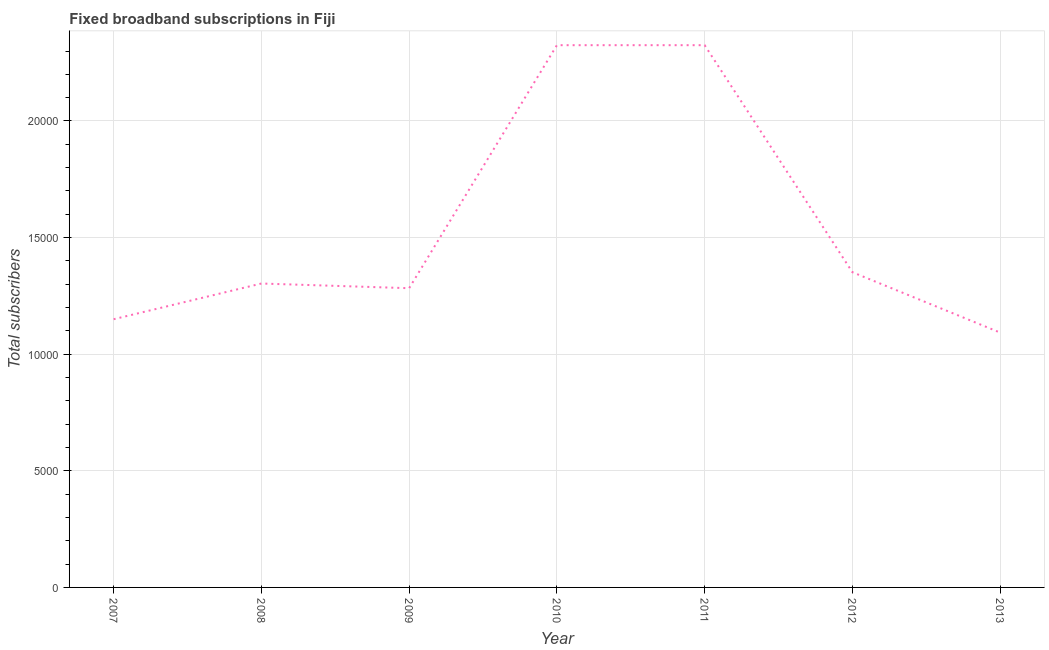What is the total number of fixed broadband subscriptions in 2010?
Your answer should be compact. 2.32e+04. Across all years, what is the maximum total number of fixed broadband subscriptions?
Give a very brief answer. 2.32e+04. Across all years, what is the minimum total number of fixed broadband subscriptions?
Your answer should be compact. 1.09e+04. In which year was the total number of fixed broadband subscriptions maximum?
Give a very brief answer. 2010. What is the sum of the total number of fixed broadband subscriptions?
Your answer should be compact. 1.08e+05. What is the average total number of fixed broadband subscriptions per year?
Provide a short and direct response. 1.55e+04. What is the median total number of fixed broadband subscriptions?
Provide a short and direct response. 1.30e+04. What is the ratio of the total number of fixed broadband subscriptions in 2010 to that in 2013?
Offer a terse response. 2.13. Is the total number of fixed broadband subscriptions in 2012 less than that in 2013?
Offer a terse response. No. Is the difference between the total number of fixed broadband subscriptions in 2008 and 2013 greater than the difference between any two years?
Ensure brevity in your answer.  No. What is the difference between the highest and the second highest total number of fixed broadband subscriptions?
Your answer should be compact. 0. Is the sum of the total number of fixed broadband subscriptions in 2007 and 2012 greater than the maximum total number of fixed broadband subscriptions across all years?
Keep it short and to the point. Yes. What is the difference between the highest and the lowest total number of fixed broadband subscriptions?
Keep it short and to the point. 1.23e+04. In how many years, is the total number of fixed broadband subscriptions greater than the average total number of fixed broadband subscriptions taken over all years?
Make the answer very short. 2. Does the total number of fixed broadband subscriptions monotonically increase over the years?
Make the answer very short. No. How many lines are there?
Provide a short and direct response. 1. How many years are there in the graph?
Ensure brevity in your answer.  7. Does the graph contain grids?
Offer a terse response. Yes. What is the title of the graph?
Keep it short and to the point. Fixed broadband subscriptions in Fiji. What is the label or title of the X-axis?
Give a very brief answer. Year. What is the label or title of the Y-axis?
Your response must be concise. Total subscribers. What is the Total subscribers of 2007?
Ensure brevity in your answer.  1.15e+04. What is the Total subscribers of 2008?
Offer a very short reply. 1.30e+04. What is the Total subscribers in 2009?
Make the answer very short. 1.28e+04. What is the Total subscribers in 2010?
Keep it short and to the point. 2.32e+04. What is the Total subscribers in 2011?
Offer a very short reply. 2.32e+04. What is the Total subscribers in 2012?
Your response must be concise. 1.35e+04. What is the Total subscribers in 2013?
Your answer should be very brief. 1.09e+04. What is the difference between the Total subscribers in 2007 and 2008?
Offer a terse response. -1531. What is the difference between the Total subscribers in 2007 and 2009?
Your answer should be compact. -1330. What is the difference between the Total subscribers in 2007 and 2010?
Your answer should be compact. -1.18e+04. What is the difference between the Total subscribers in 2007 and 2011?
Offer a terse response. -1.18e+04. What is the difference between the Total subscribers in 2007 and 2012?
Make the answer very short. -2016. What is the difference between the Total subscribers in 2007 and 2013?
Provide a short and direct response. 573. What is the difference between the Total subscribers in 2008 and 2009?
Keep it short and to the point. 201. What is the difference between the Total subscribers in 2008 and 2010?
Your answer should be compact. -1.02e+04. What is the difference between the Total subscribers in 2008 and 2011?
Provide a short and direct response. -1.02e+04. What is the difference between the Total subscribers in 2008 and 2012?
Offer a very short reply. -485. What is the difference between the Total subscribers in 2008 and 2013?
Give a very brief answer. 2104. What is the difference between the Total subscribers in 2009 and 2010?
Give a very brief answer. -1.04e+04. What is the difference between the Total subscribers in 2009 and 2011?
Make the answer very short. -1.04e+04. What is the difference between the Total subscribers in 2009 and 2012?
Your answer should be very brief. -686. What is the difference between the Total subscribers in 2009 and 2013?
Keep it short and to the point. 1903. What is the difference between the Total subscribers in 2010 and 2011?
Offer a very short reply. 0. What is the difference between the Total subscribers in 2010 and 2012?
Provide a short and direct response. 9734. What is the difference between the Total subscribers in 2010 and 2013?
Provide a succinct answer. 1.23e+04. What is the difference between the Total subscribers in 2011 and 2012?
Make the answer very short. 9734. What is the difference between the Total subscribers in 2011 and 2013?
Offer a terse response. 1.23e+04. What is the difference between the Total subscribers in 2012 and 2013?
Offer a terse response. 2589. What is the ratio of the Total subscribers in 2007 to that in 2008?
Your answer should be very brief. 0.88. What is the ratio of the Total subscribers in 2007 to that in 2009?
Your answer should be very brief. 0.9. What is the ratio of the Total subscribers in 2007 to that in 2010?
Provide a succinct answer. 0.49. What is the ratio of the Total subscribers in 2007 to that in 2011?
Give a very brief answer. 0.49. What is the ratio of the Total subscribers in 2007 to that in 2012?
Offer a terse response. 0.85. What is the ratio of the Total subscribers in 2007 to that in 2013?
Your answer should be compact. 1.05. What is the ratio of the Total subscribers in 2008 to that in 2010?
Offer a terse response. 0.56. What is the ratio of the Total subscribers in 2008 to that in 2011?
Keep it short and to the point. 0.56. What is the ratio of the Total subscribers in 2008 to that in 2013?
Provide a short and direct response. 1.19. What is the ratio of the Total subscribers in 2009 to that in 2010?
Your response must be concise. 0.55. What is the ratio of the Total subscribers in 2009 to that in 2011?
Offer a very short reply. 0.55. What is the ratio of the Total subscribers in 2009 to that in 2012?
Your answer should be compact. 0.95. What is the ratio of the Total subscribers in 2009 to that in 2013?
Offer a very short reply. 1.17. What is the ratio of the Total subscribers in 2010 to that in 2012?
Keep it short and to the point. 1.72. What is the ratio of the Total subscribers in 2010 to that in 2013?
Your response must be concise. 2.13. What is the ratio of the Total subscribers in 2011 to that in 2012?
Offer a very short reply. 1.72. What is the ratio of the Total subscribers in 2011 to that in 2013?
Ensure brevity in your answer.  2.13. What is the ratio of the Total subscribers in 2012 to that in 2013?
Your answer should be compact. 1.24. 